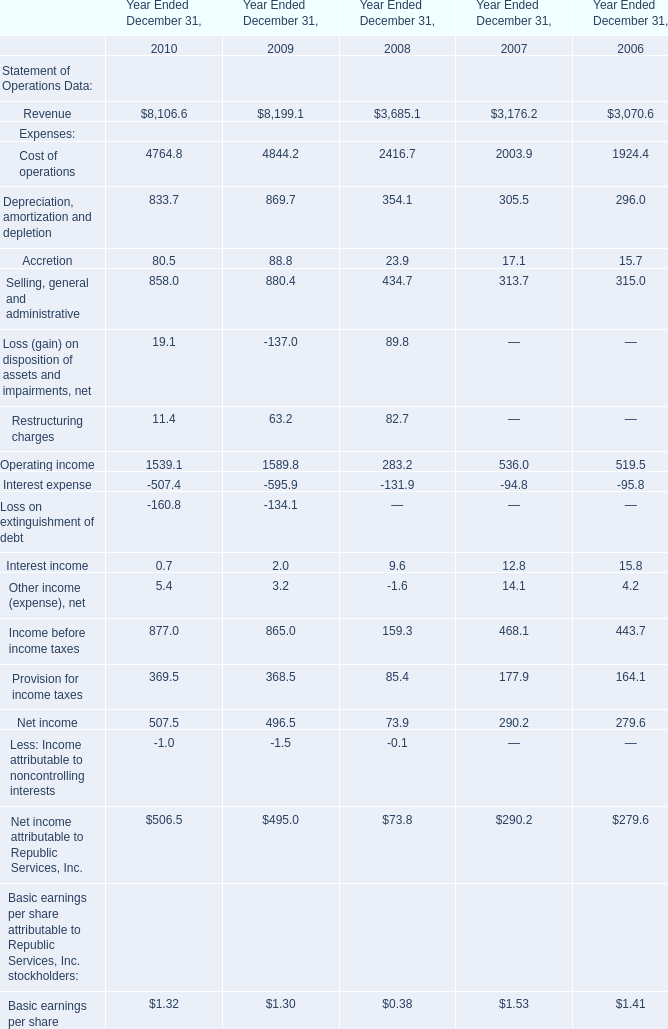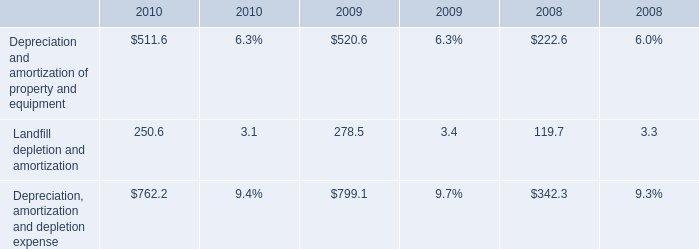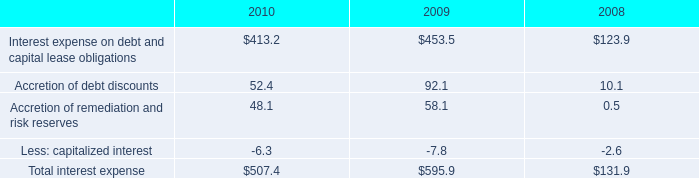In the year with largest amount of Revenue, what's the sum ofCost of operations ? 
Computations: (4764.8 + 4844.2)
Answer: 9609.0. 